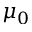Convert formula to latex. <formula><loc_0><loc_0><loc_500><loc_500>\mu _ { 0 }</formula> 